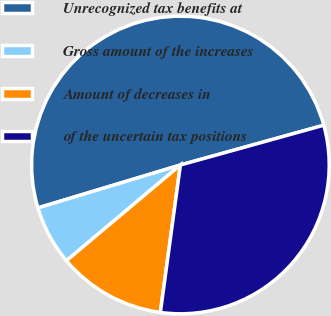Convert chart to OTSL. <chart><loc_0><loc_0><loc_500><loc_500><pie_chart><fcel>Unrecognized tax benefits at<fcel>Gross amount of the increases<fcel>Amount of decreases in<fcel>of the uncertain tax positions<nl><fcel>50.35%<fcel>6.46%<fcel>11.73%<fcel>31.46%<nl></chart> 